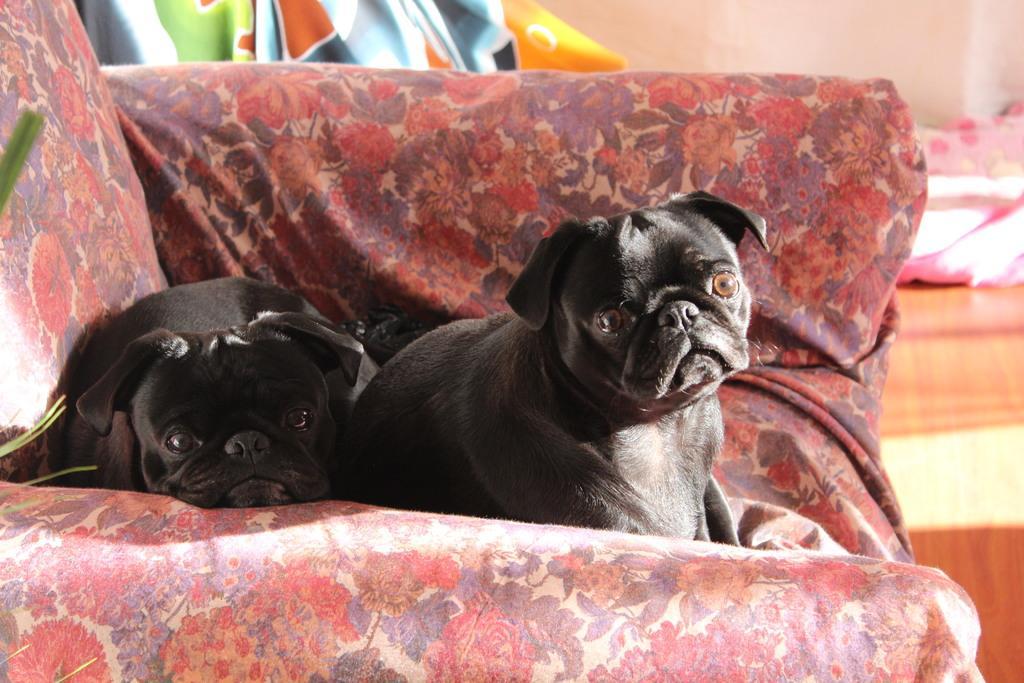Can you describe this image briefly? In this image, we can see dogs on the sofa. 